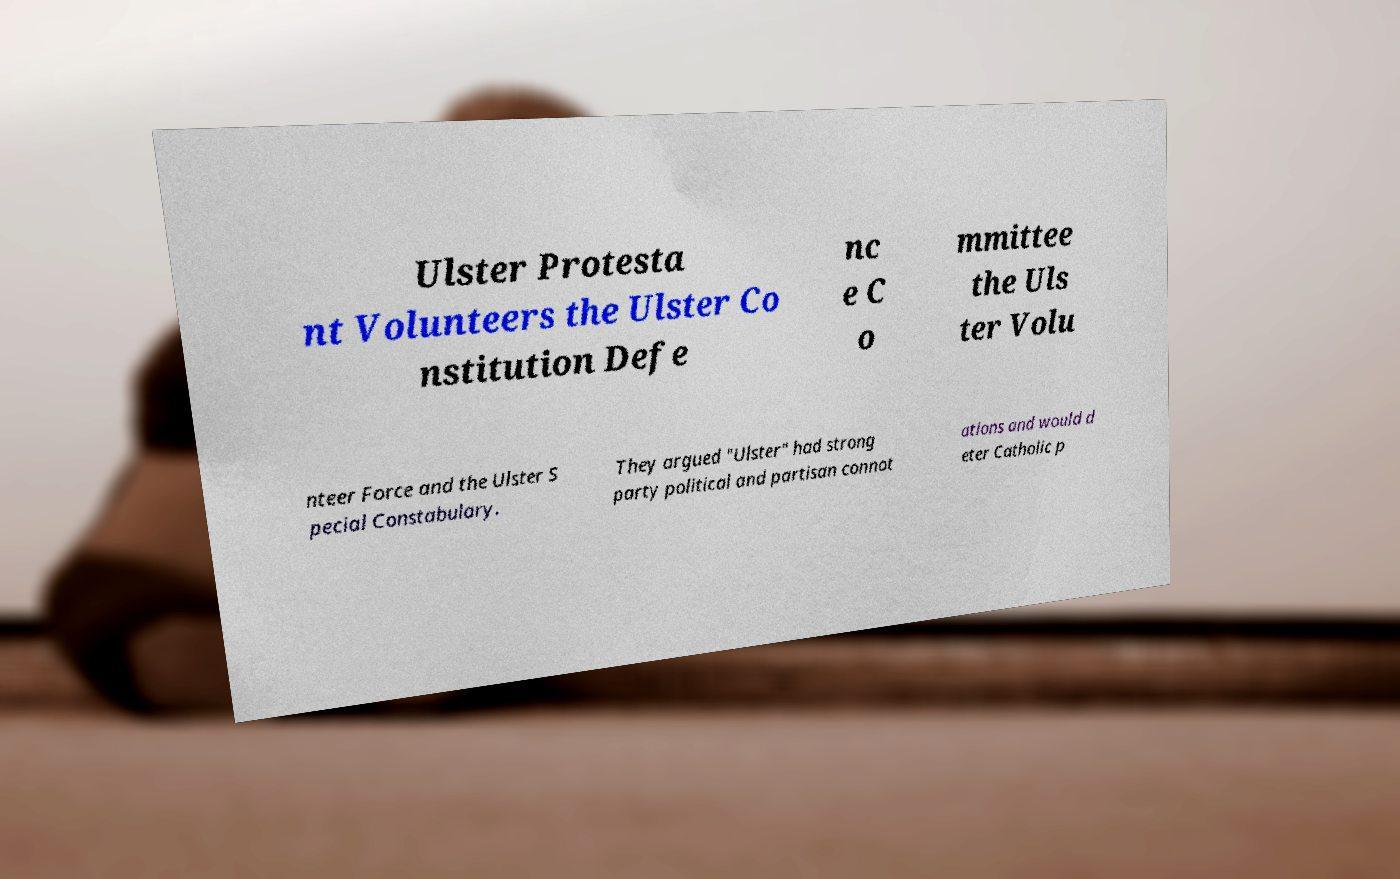Please read and relay the text visible in this image. What does it say? Ulster Protesta nt Volunteers the Ulster Co nstitution Defe nc e C o mmittee the Uls ter Volu nteer Force and the Ulster S pecial Constabulary. They argued "Ulster" had strong party political and partisan connot ations and would d eter Catholic p 